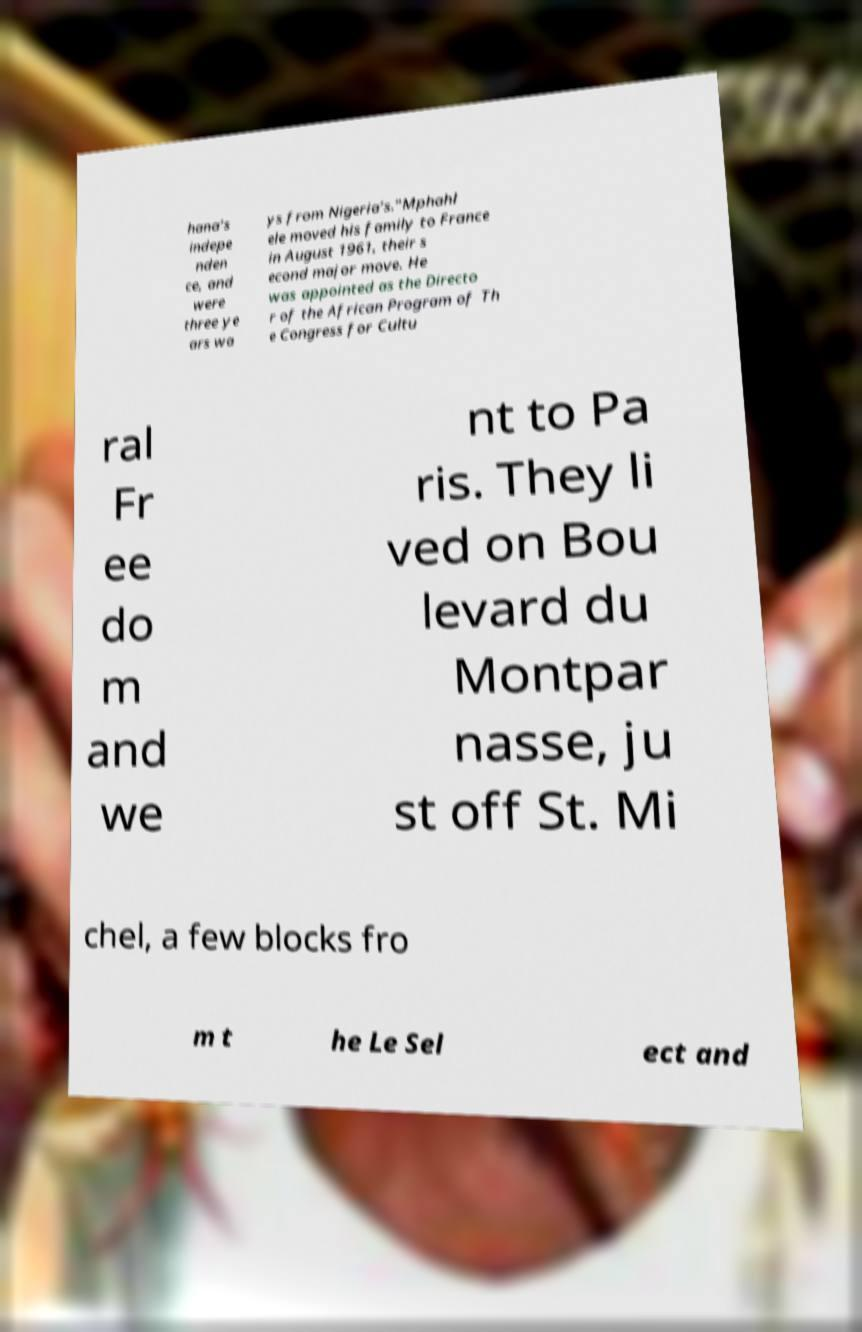What messages or text are displayed in this image? I need them in a readable, typed format. hana’s indepe nden ce, and were three ye ars wa ys from Nigeria’s."Mphahl ele moved his family to France in August 1961, their s econd major move. He was appointed as the Directo r of the African Program of Th e Congress for Cultu ral Fr ee do m and we nt to Pa ris. They li ved on Bou levard du Montpar nasse, ju st off St. Mi chel, a few blocks fro m t he Le Sel ect and 